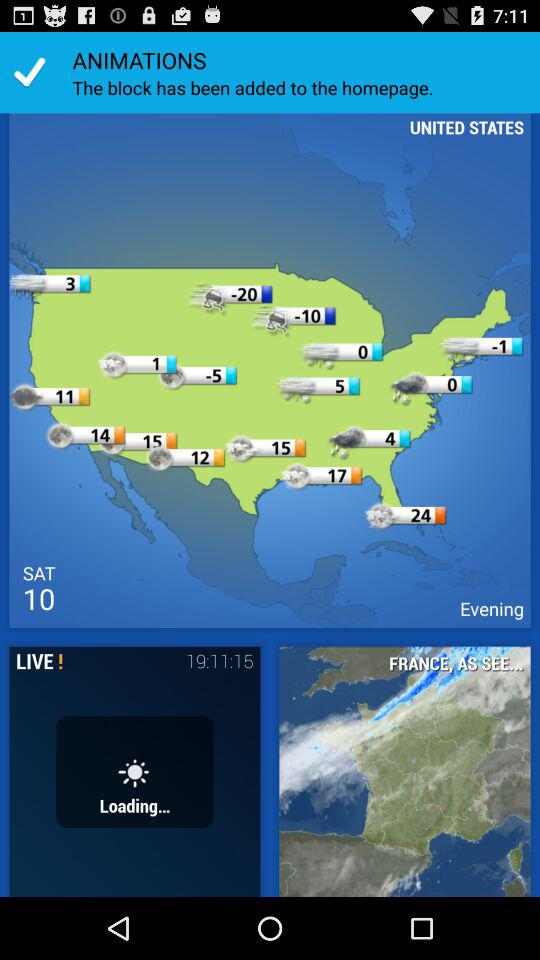Which day is mentioned? The mentioned day is Saturday. 